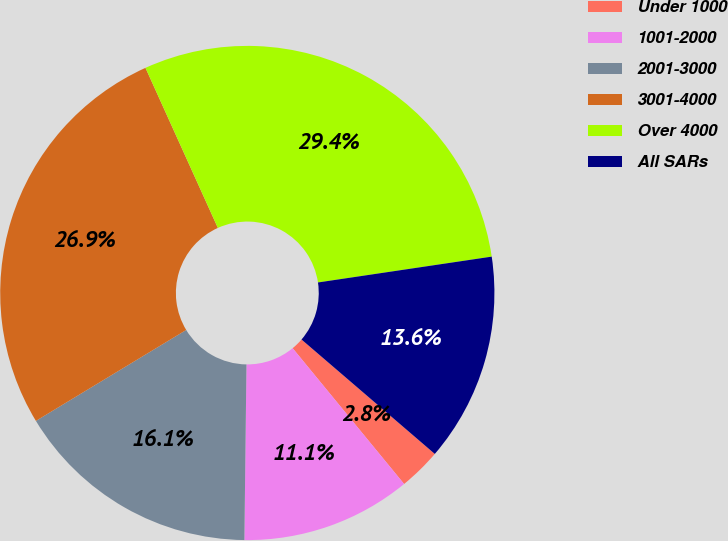Convert chart. <chart><loc_0><loc_0><loc_500><loc_500><pie_chart><fcel>Under 1000<fcel>1001-2000<fcel>2001-3000<fcel>3001-4000<fcel>Over 4000<fcel>All SARs<nl><fcel>2.77%<fcel>11.13%<fcel>16.15%<fcel>26.9%<fcel>29.41%<fcel>13.64%<nl></chart> 